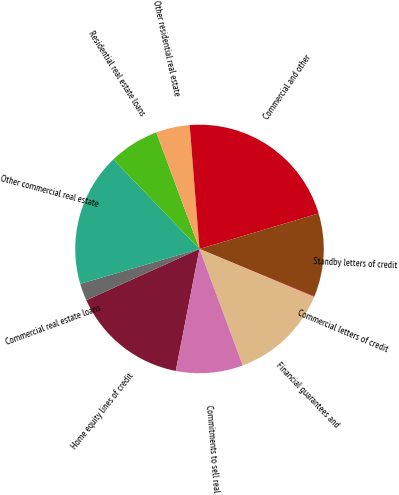Convert chart. <chart><loc_0><loc_0><loc_500><loc_500><pie_chart><fcel>Home equity lines of credit<fcel>Commercial real estate loans<fcel>Other commercial real estate<fcel>Residential real estate loans<fcel>Other residential real estate<fcel>Commercial and other<fcel>Standby letters of credit<fcel>Commercial letters of credit<fcel>Financial guarantees and<fcel>Commitments to sell real<nl><fcel>15.18%<fcel>2.24%<fcel>17.33%<fcel>6.55%<fcel>4.39%<fcel>21.65%<fcel>10.86%<fcel>0.08%<fcel>13.02%<fcel>8.71%<nl></chart> 